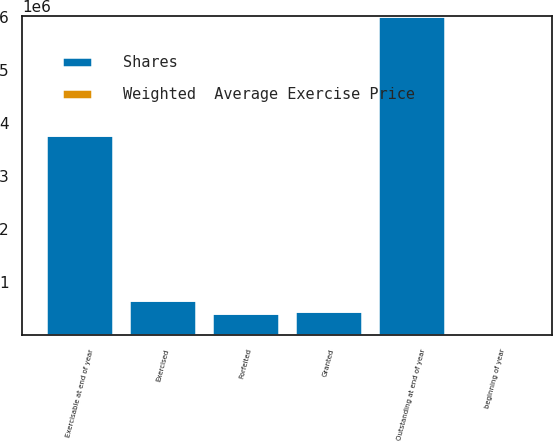<chart> <loc_0><loc_0><loc_500><loc_500><stacked_bar_chart><ecel><fcel>beginning of year<fcel>Granted<fcel>Exercised<fcel>Forfeited<fcel>Outstanding at end of year<fcel>Exercisable at end of year<nl><fcel>Shares<fcel>44.81<fcel>449315<fcel>656688<fcel>414932<fcel>6.02446e+06<fcel>3.77563e+06<nl><fcel>Weighted  Average Exercise Price<fcel>27.4<fcel>44.81<fcel>22.93<fcel>32.11<fcel>28.84<fcel>25.43<nl></chart> 